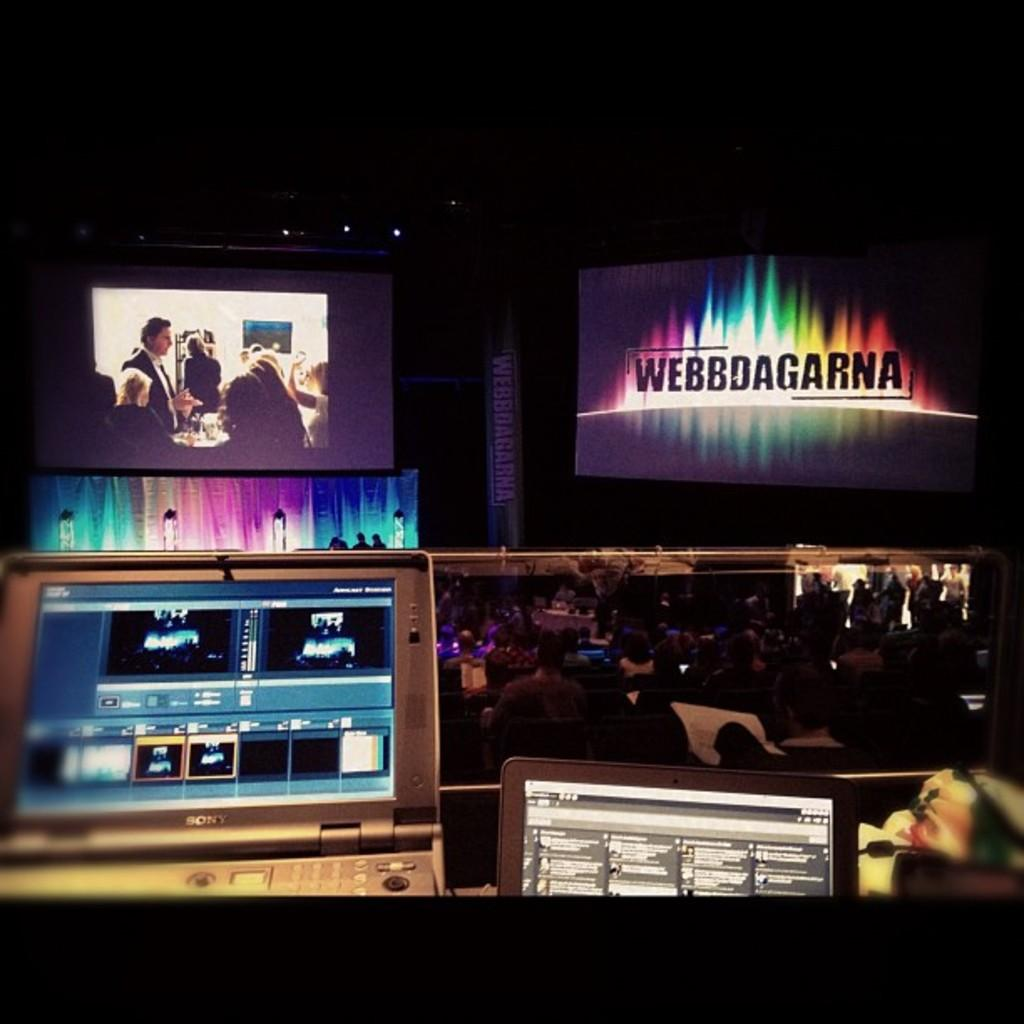What electronic devices can be seen in the image? There are laptops in the image. What is displayed on the laptops? There are screens in the image. What type of illumination is present in the image? There are lights in the image. What kind of signage is visible in the image? There is a banner in the image. What other objects can be seen in the image? There are some objects in the image. Who is present in the image? There is a group of people in the image. How would you describe the lighting conditions in the image? The background of the image is dark. What type of crime is being committed in the image? There is no indication of any crime being committed in the image. How hot is the temperature in the image? The temperature cannot be determined from the image alone. Are there any snails visible in the image? There are no snails present in the image. 